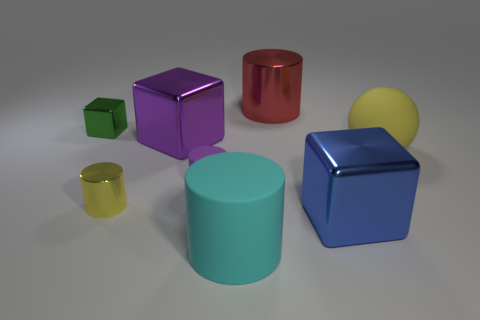There is a big purple object; is it the same shape as the small metallic object that is in front of the tiny green metal object?
Your answer should be compact. No. What size is the metal block that is the same color as the small matte thing?
Your answer should be very brief. Large. What number of things are either tiny yellow cylinders or blue things?
Ensure brevity in your answer.  2. What shape is the matte object that is on the right side of the cyan cylinder in front of the large blue object?
Ensure brevity in your answer.  Sphere. There is a matte object left of the cyan rubber cylinder; is its shape the same as the small yellow metal object?
Provide a succinct answer. Yes. What is the size of the red cylinder that is the same material as the large purple object?
Your response must be concise. Large. How many objects are yellow things that are to the right of the large cyan thing or shiny cubes that are in front of the green cube?
Make the answer very short. 3. Are there the same number of red metal cylinders to the right of the blue metallic thing and large yellow matte objects to the right of the big yellow rubber sphere?
Offer a very short reply. Yes. What color is the big matte object on the right side of the large blue metallic block?
Offer a very short reply. Yellow. Do the small cube and the metal cylinder that is in front of the big purple metallic block have the same color?
Your answer should be very brief. No. 